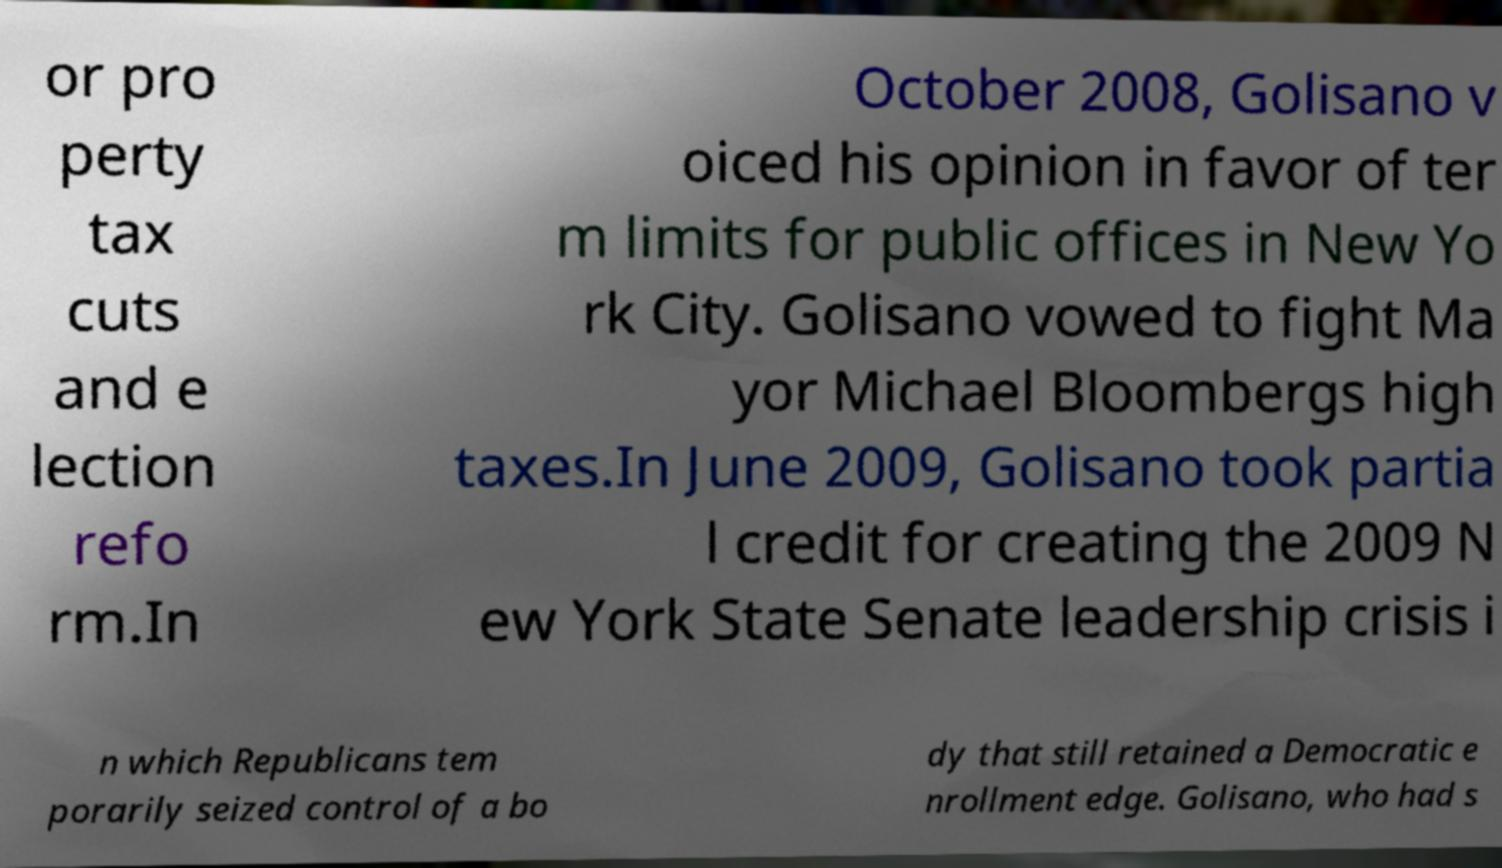Could you assist in decoding the text presented in this image and type it out clearly? or pro perty tax cuts and e lection refo rm.In October 2008, Golisano v oiced his opinion in favor of ter m limits for public offices in New Yo rk City. Golisano vowed to fight Ma yor Michael Bloombergs high taxes.In June 2009, Golisano took partia l credit for creating the 2009 N ew York State Senate leadership crisis i n which Republicans tem porarily seized control of a bo dy that still retained a Democratic e nrollment edge. Golisano, who had s 